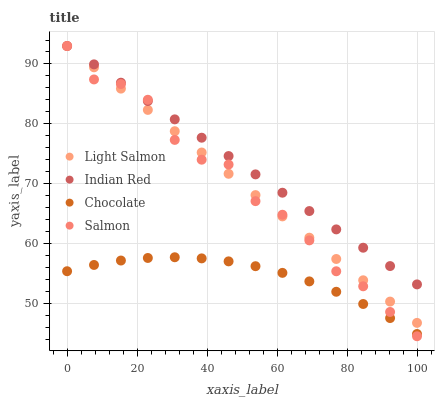Does Chocolate have the minimum area under the curve?
Answer yes or no. Yes. Does Indian Red have the maximum area under the curve?
Answer yes or no. Yes. Does Salmon have the minimum area under the curve?
Answer yes or no. No. Does Salmon have the maximum area under the curve?
Answer yes or no. No. Is Light Salmon the smoothest?
Answer yes or no. Yes. Is Salmon the roughest?
Answer yes or no. Yes. Is Indian Red the smoothest?
Answer yes or no. No. Is Indian Red the roughest?
Answer yes or no. No. Does Salmon have the lowest value?
Answer yes or no. Yes. Does Indian Red have the lowest value?
Answer yes or no. No. Does Indian Red have the highest value?
Answer yes or no. Yes. Does Chocolate have the highest value?
Answer yes or no. No. Is Chocolate less than Light Salmon?
Answer yes or no. Yes. Is Light Salmon greater than Chocolate?
Answer yes or no. Yes. Does Light Salmon intersect Indian Red?
Answer yes or no. Yes. Is Light Salmon less than Indian Red?
Answer yes or no. No. Is Light Salmon greater than Indian Red?
Answer yes or no. No. Does Chocolate intersect Light Salmon?
Answer yes or no. No. 